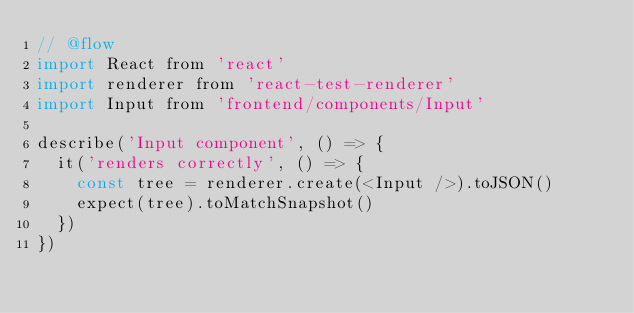Convert code to text. <code><loc_0><loc_0><loc_500><loc_500><_JavaScript_>// @flow
import React from 'react'
import renderer from 'react-test-renderer'
import Input from 'frontend/components/Input'

describe('Input component', () => {
  it('renders correctly', () => {
    const tree = renderer.create(<Input />).toJSON()
    expect(tree).toMatchSnapshot()
  })
})
</code> 